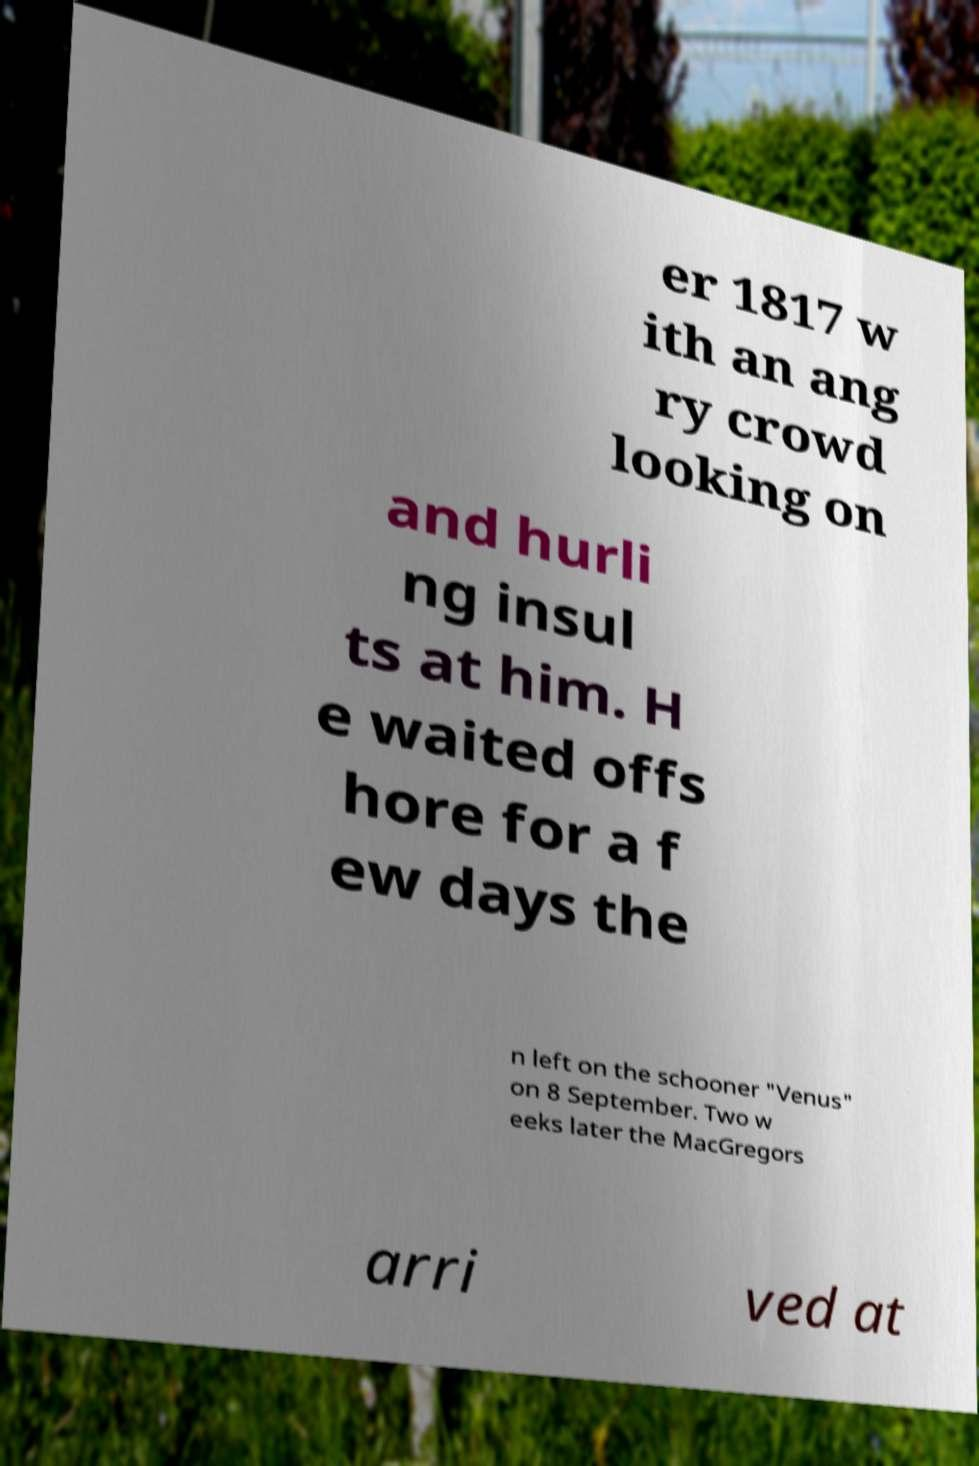I need the written content from this picture converted into text. Can you do that? er 1817 w ith an ang ry crowd looking on and hurli ng insul ts at him. H e waited offs hore for a f ew days the n left on the schooner "Venus" on 8 September. Two w eeks later the MacGregors arri ved at 